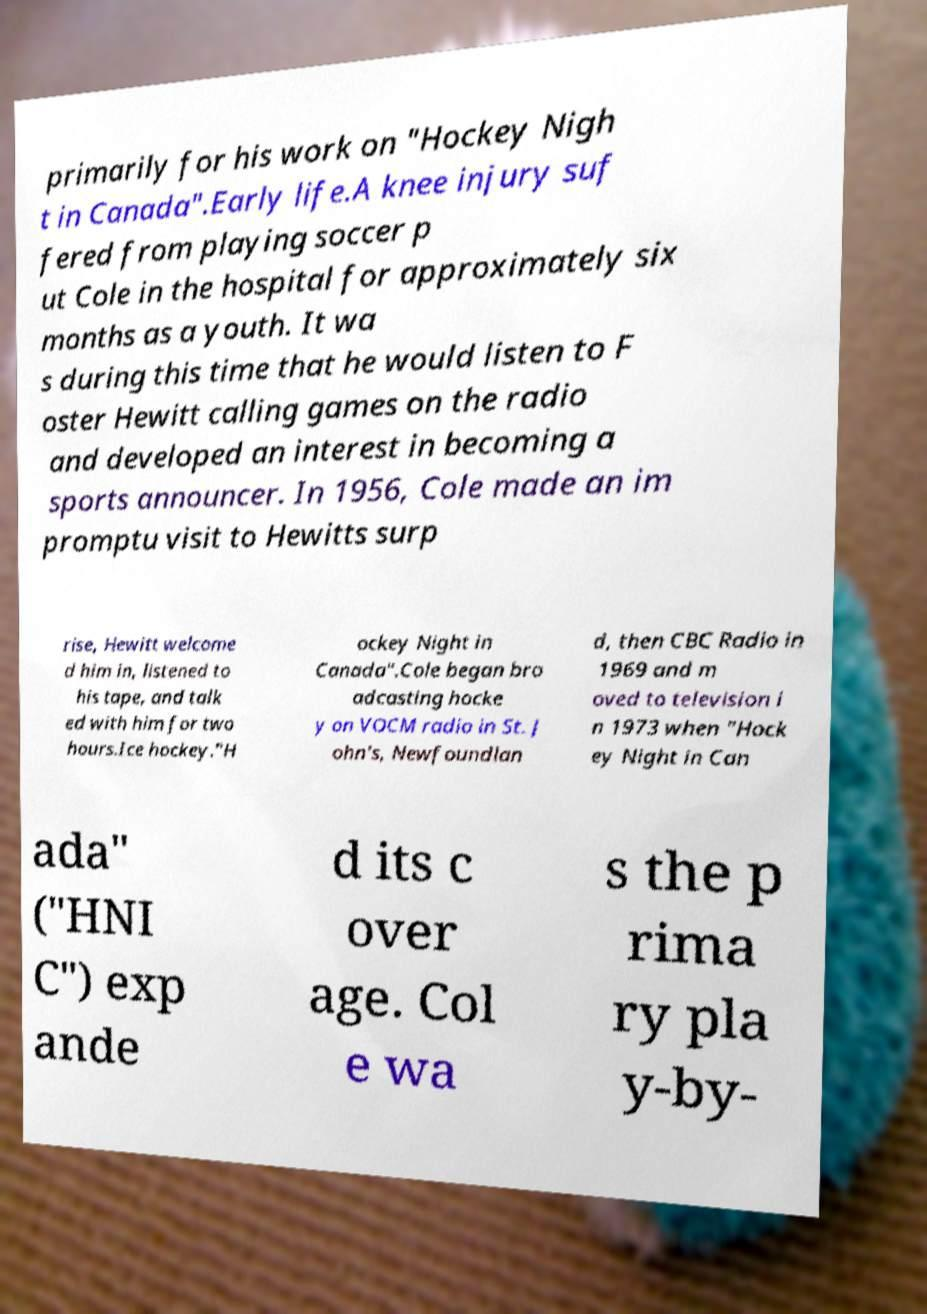What messages or text are displayed in this image? I need them in a readable, typed format. primarily for his work on "Hockey Nigh t in Canada".Early life.A knee injury suf fered from playing soccer p ut Cole in the hospital for approximately six months as a youth. It wa s during this time that he would listen to F oster Hewitt calling games on the radio and developed an interest in becoming a sports announcer. In 1956, Cole made an im promptu visit to Hewitts surp rise, Hewitt welcome d him in, listened to his tape, and talk ed with him for two hours.Ice hockey."H ockey Night in Canada".Cole began bro adcasting hocke y on VOCM radio in St. J ohn's, Newfoundlan d, then CBC Radio in 1969 and m oved to television i n 1973 when "Hock ey Night in Can ada" ("HNI C") exp ande d its c over age. Col e wa s the p rima ry pla y-by- 